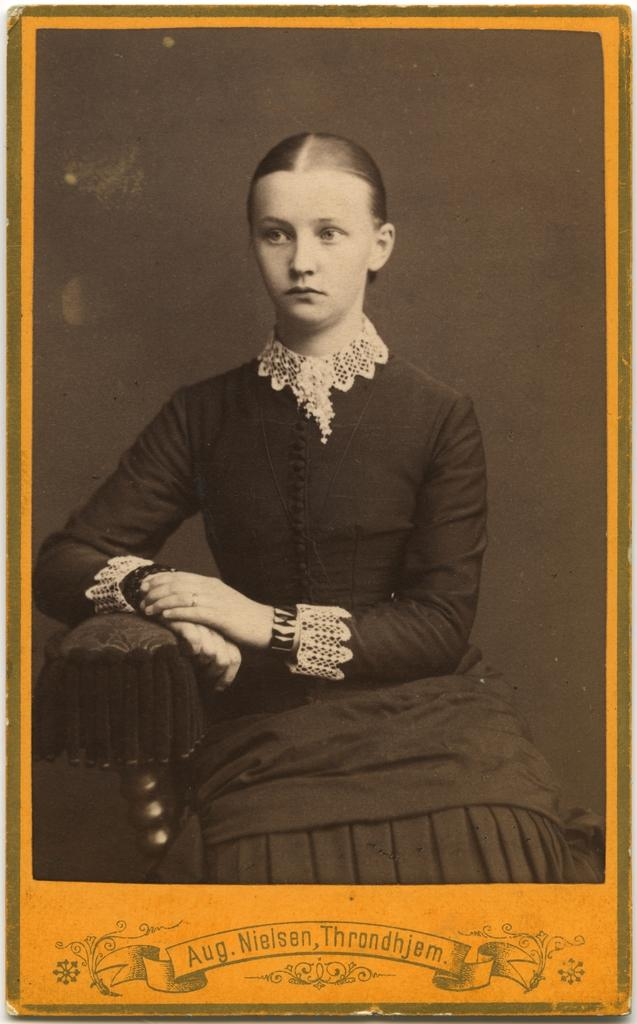What is the woman in the image doing? The woman is sitting in the image. Can you describe any text that is visible in the image? Yes, there is text at the bottom of the image. Is there a camera visible in the image? No, there is no camera present in the image. Can you see any cobwebs in the image? No, there are no cobwebs visible in the image. 